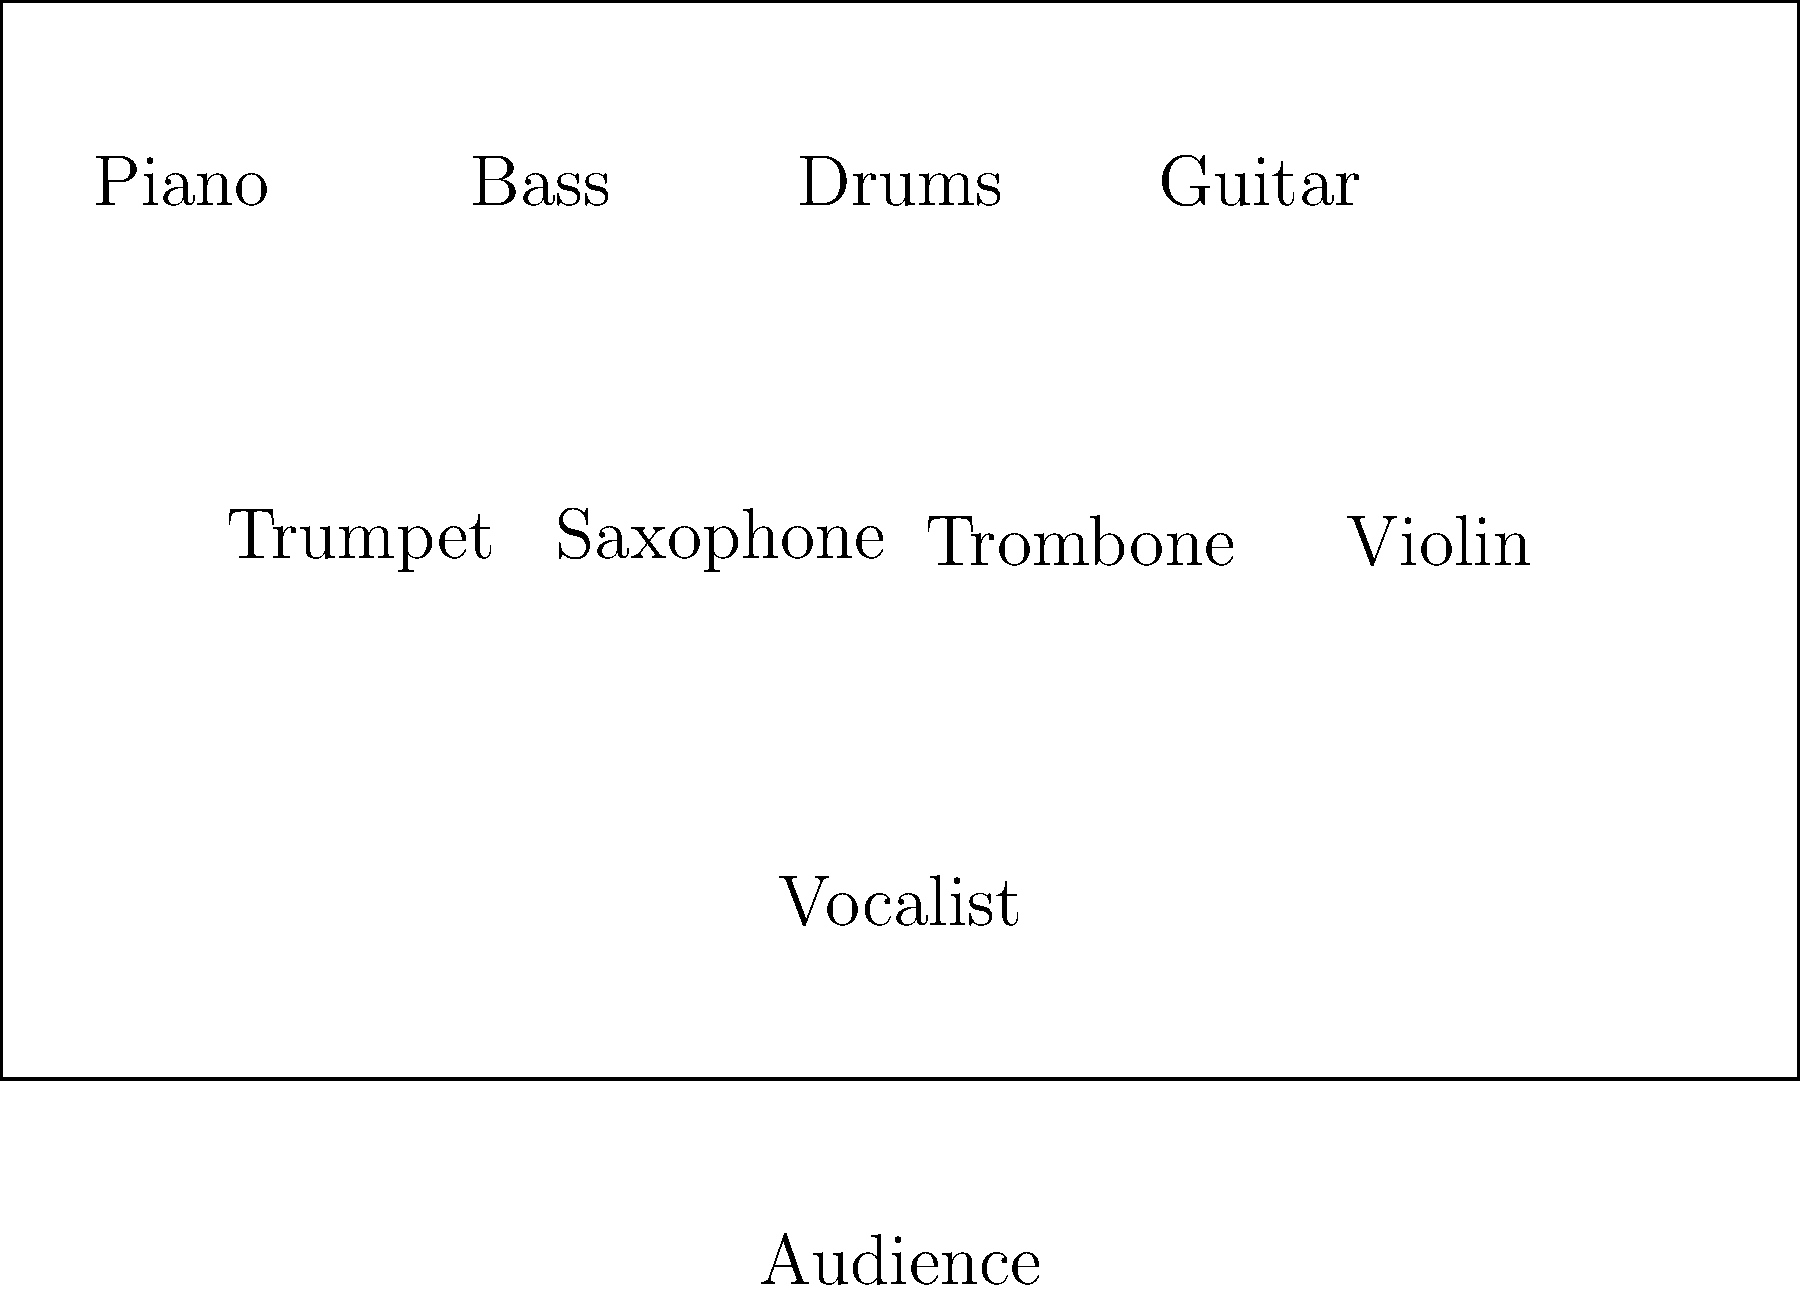In a typical jazz ensemble setup, which instrument is usually positioned closest to the audience and serves as the focal point for performances? To answer this question, let's analyze the typical jazz ensemble setup step-by-step:

1. The rhythm section (piano, bass, drums, and often guitar) is usually positioned at the back of the stage. This allows them to provide a solid foundation for the rest of the ensemble.

2. The horn section (trumpet, saxophone, trombone) is typically placed in the middle of the stage, allowing for clear projection of their sound.

3. Additional instruments like the violin (which Joe Deninzon is known for) are often positioned alongside the horn section.

4. The vocalist, when present, is usually placed at the front of the stage, closest to the audience.

5. This placement of the vocalist serves several purposes:
   a) It allows for better audience engagement and connection.
   b) It ensures the vocalist's voice can be heard clearly over the instruments.
   c) It creates a visual focal point for the performance.

6. Even in instrumental jazz performances without a vocalist, the soloist often steps forward when it's their turn to improvise, temporarily taking on this focal point role.

Given this typical setup, the vocalist (or featured soloist) is usually positioned closest to the audience and serves as the focal point for performances.
Answer: Vocalist 